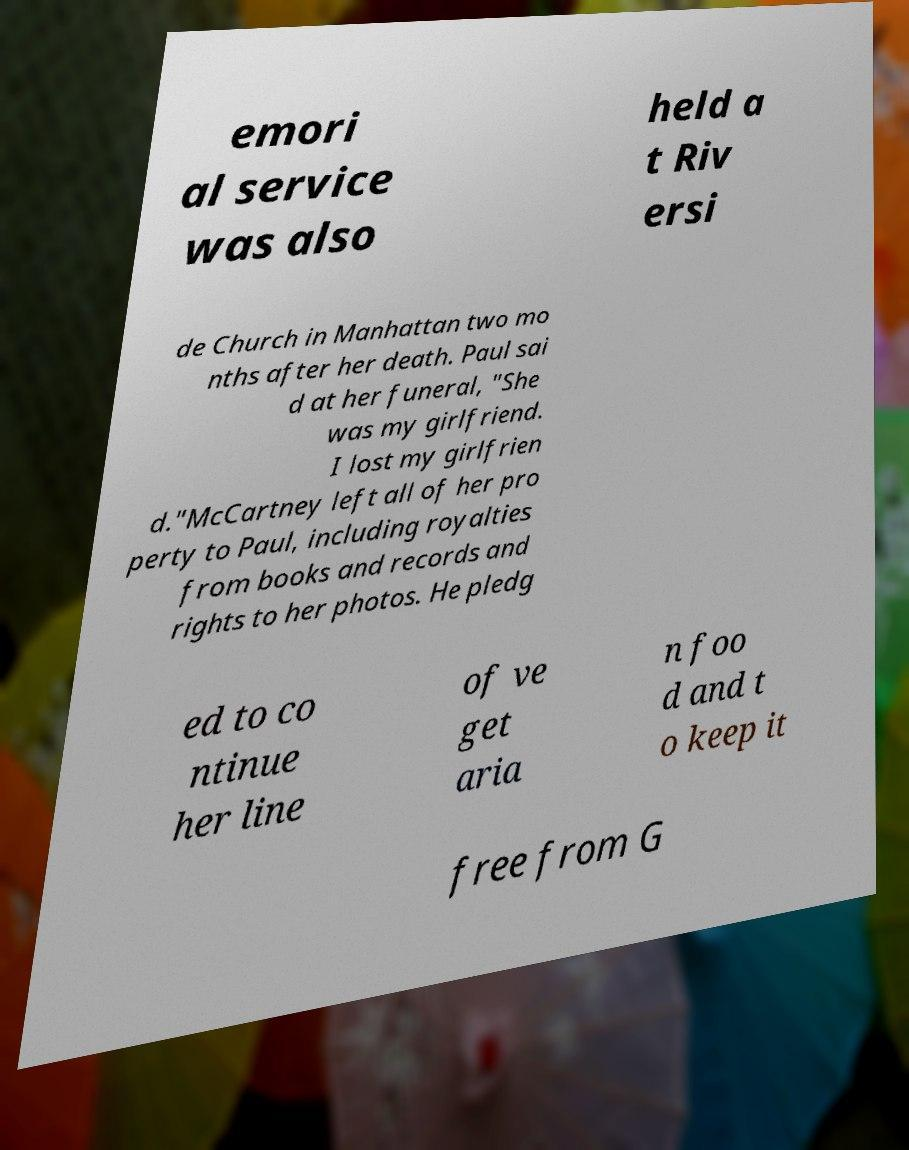Could you assist in decoding the text presented in this image and type it out clearly? emori al service was also held a t Riv ersi de Church in Manhattan two mo nths after her death. Paul sai d at her funeral, "She was my girlfriend. I lost my girlfrien d."McCartney left all of her pro perty to Paul, including royalties from books and records and rights to her photos. He pledg ed to co ntinue her line of ve get aria n foo d and t o keep it free from G 